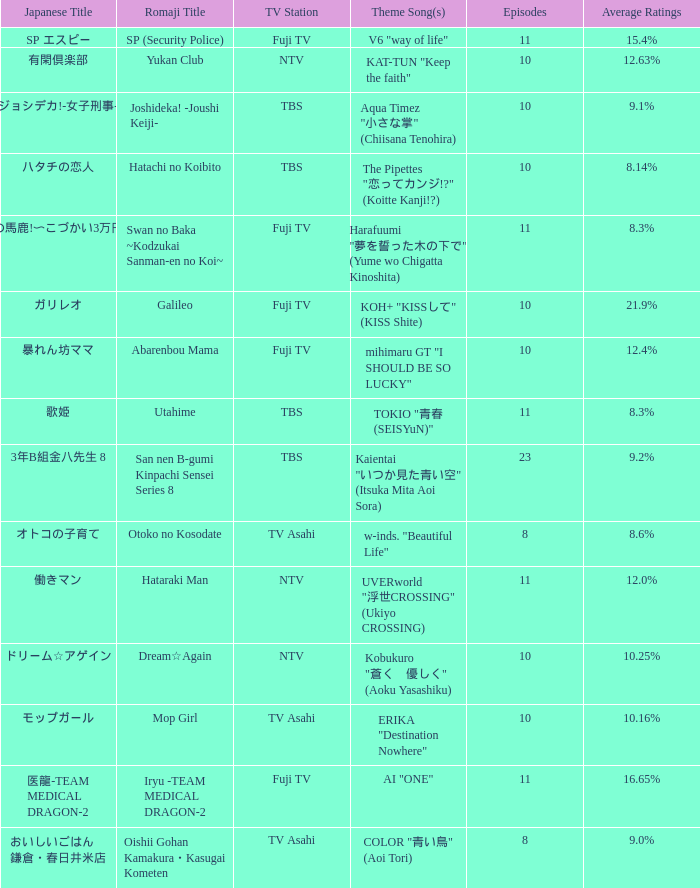Could you parse the entire table? {'header': ['Japanese Title', 'Romaji Title', 'TV Station', 'Theme Song(s)', 'Episodes', 'Average Ratings'], 'rows': [['SP エスピー', 'SP (Security Police)', 'Fuji TV', 'V6 "way of life"', '11', '15.4%'], ['有閑倶楽部', 'Yukan Club', 'NTV', 'KAT-TUN "Keep the faith"', '10', '12.63%'], ['ジョシデカ!-女子刑事-', 'Joshideka! -Joushi Keiji-', 'TBS', 'Aqua Timez "小さな掌" (Chiisana Tenohira)', '10', '9.1%'], ['ハタチの恋人', 'Hatachi no Koibito', 'TBS', 'The Pipettes "恋ってカンジ!?" (Koitte Kanji!?)', '10', '8.14%'], ['スワンの馬鹿!〜こづかい3万円の恋〜', 'Swan no Baka ~Kodzukai Sanman-en no Koi~', 'Fuji TV', 'Harafuumi "夢を誓った木の下で" (Yume wo Chigatta Kinoshita)', '11', '8.3%'], ['ガリレオ', 'Galileo', 'Fuji TV', 'KOH+ "KISSして" (KISS Shite)', '10', '21.9%'], ['暴れん坊ママ', 'Abarenbou Mama', 'Fuji TV', 'mihimaru GT "I SHOULD BE SO LUCKY"', '10', '12.4%'], ['歌姫', 'Utahime', 'TBS', 'TOKIO "青春 (SEISYuN)"', '11', '8.3%'], ['3年B組金八先生 8', 'San nen B-gumi Kinpachi Sensei Series 8', 'TBS', 'Kaientai "いつか見た青い空" (Itsuka Mita Aoi Sora)', '23', '9.2%'], ['オトコの子育て', 'Otoko no Kosodate', 'TV Asahi', 'w-inds. "Beautiful Life"', '8', '8.6%'], ['働きマン', 'Hataraki Man', 'NTV', 'UVERworld "浮世CROSSING" (Ukiyo CROSSING)', '11', '12.0%'], ['ドリーム☆アゲイン', 'Dream☆Again', 'NTV', 'Kobukuro "蒼く\u3000優しく" (Aoku Yasashiku)', '10', '10.25%'], ['モップガール', 'Mop Girl', 'TV Asahi', 'ERIKA "Destination Nowhere"', '10', '10.16%'], ['医龍-TEAM MEDICAL DRAGON-2', 'Iryu -TEAM MEDICAL DRAGON-2', 'Fuji TV', 'AI "ONE"', '11', '16.65%'], ['おいしいごはん 鎌倉・春日井米店', 'Oishii Gohan Kamakura・Kasugai Kometen', 'TV Asahi', 'COLOR "青い鳥" (Aoi Tori)', '8', '9.0%']]} What is the Theme Song of Iryu -Team Medical Dragon-2? AI "ONE". 